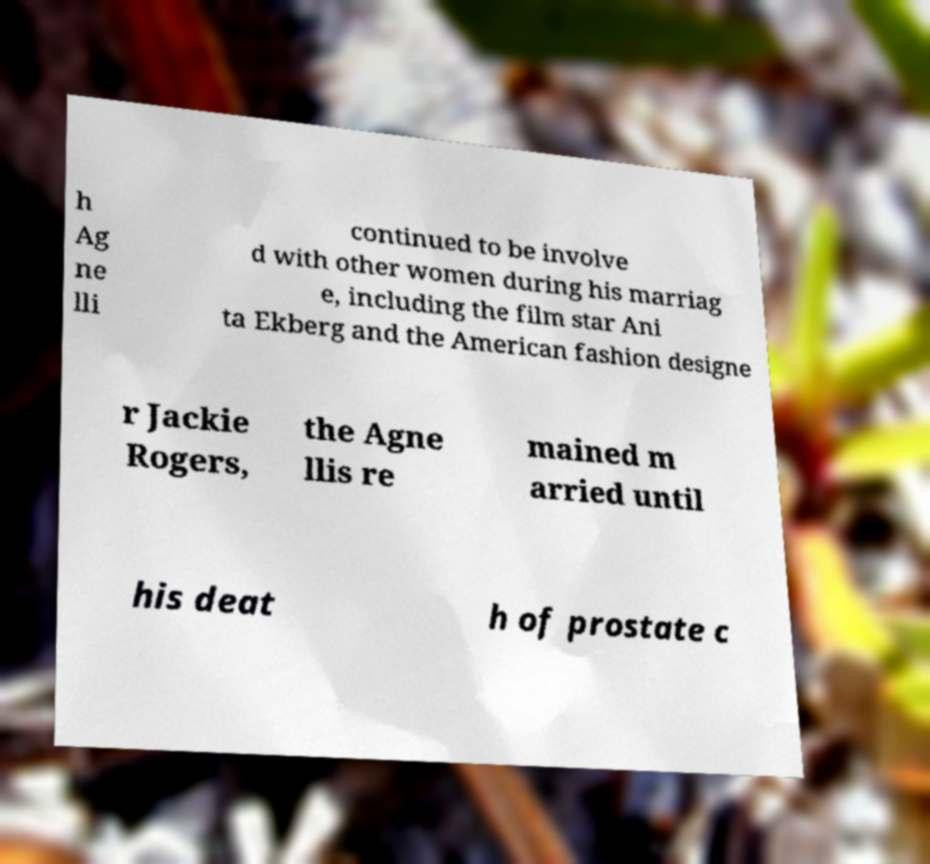Could you assist in decoding the text presented in this image and type it out clearly? h Ag ne lli continued to be involve d with other women during his marriag e, including the film star Ani ta Ekberg and the American fashion designe r Jackie Rogers, the Agne llis re mained m arried until his deat h of prostate c 